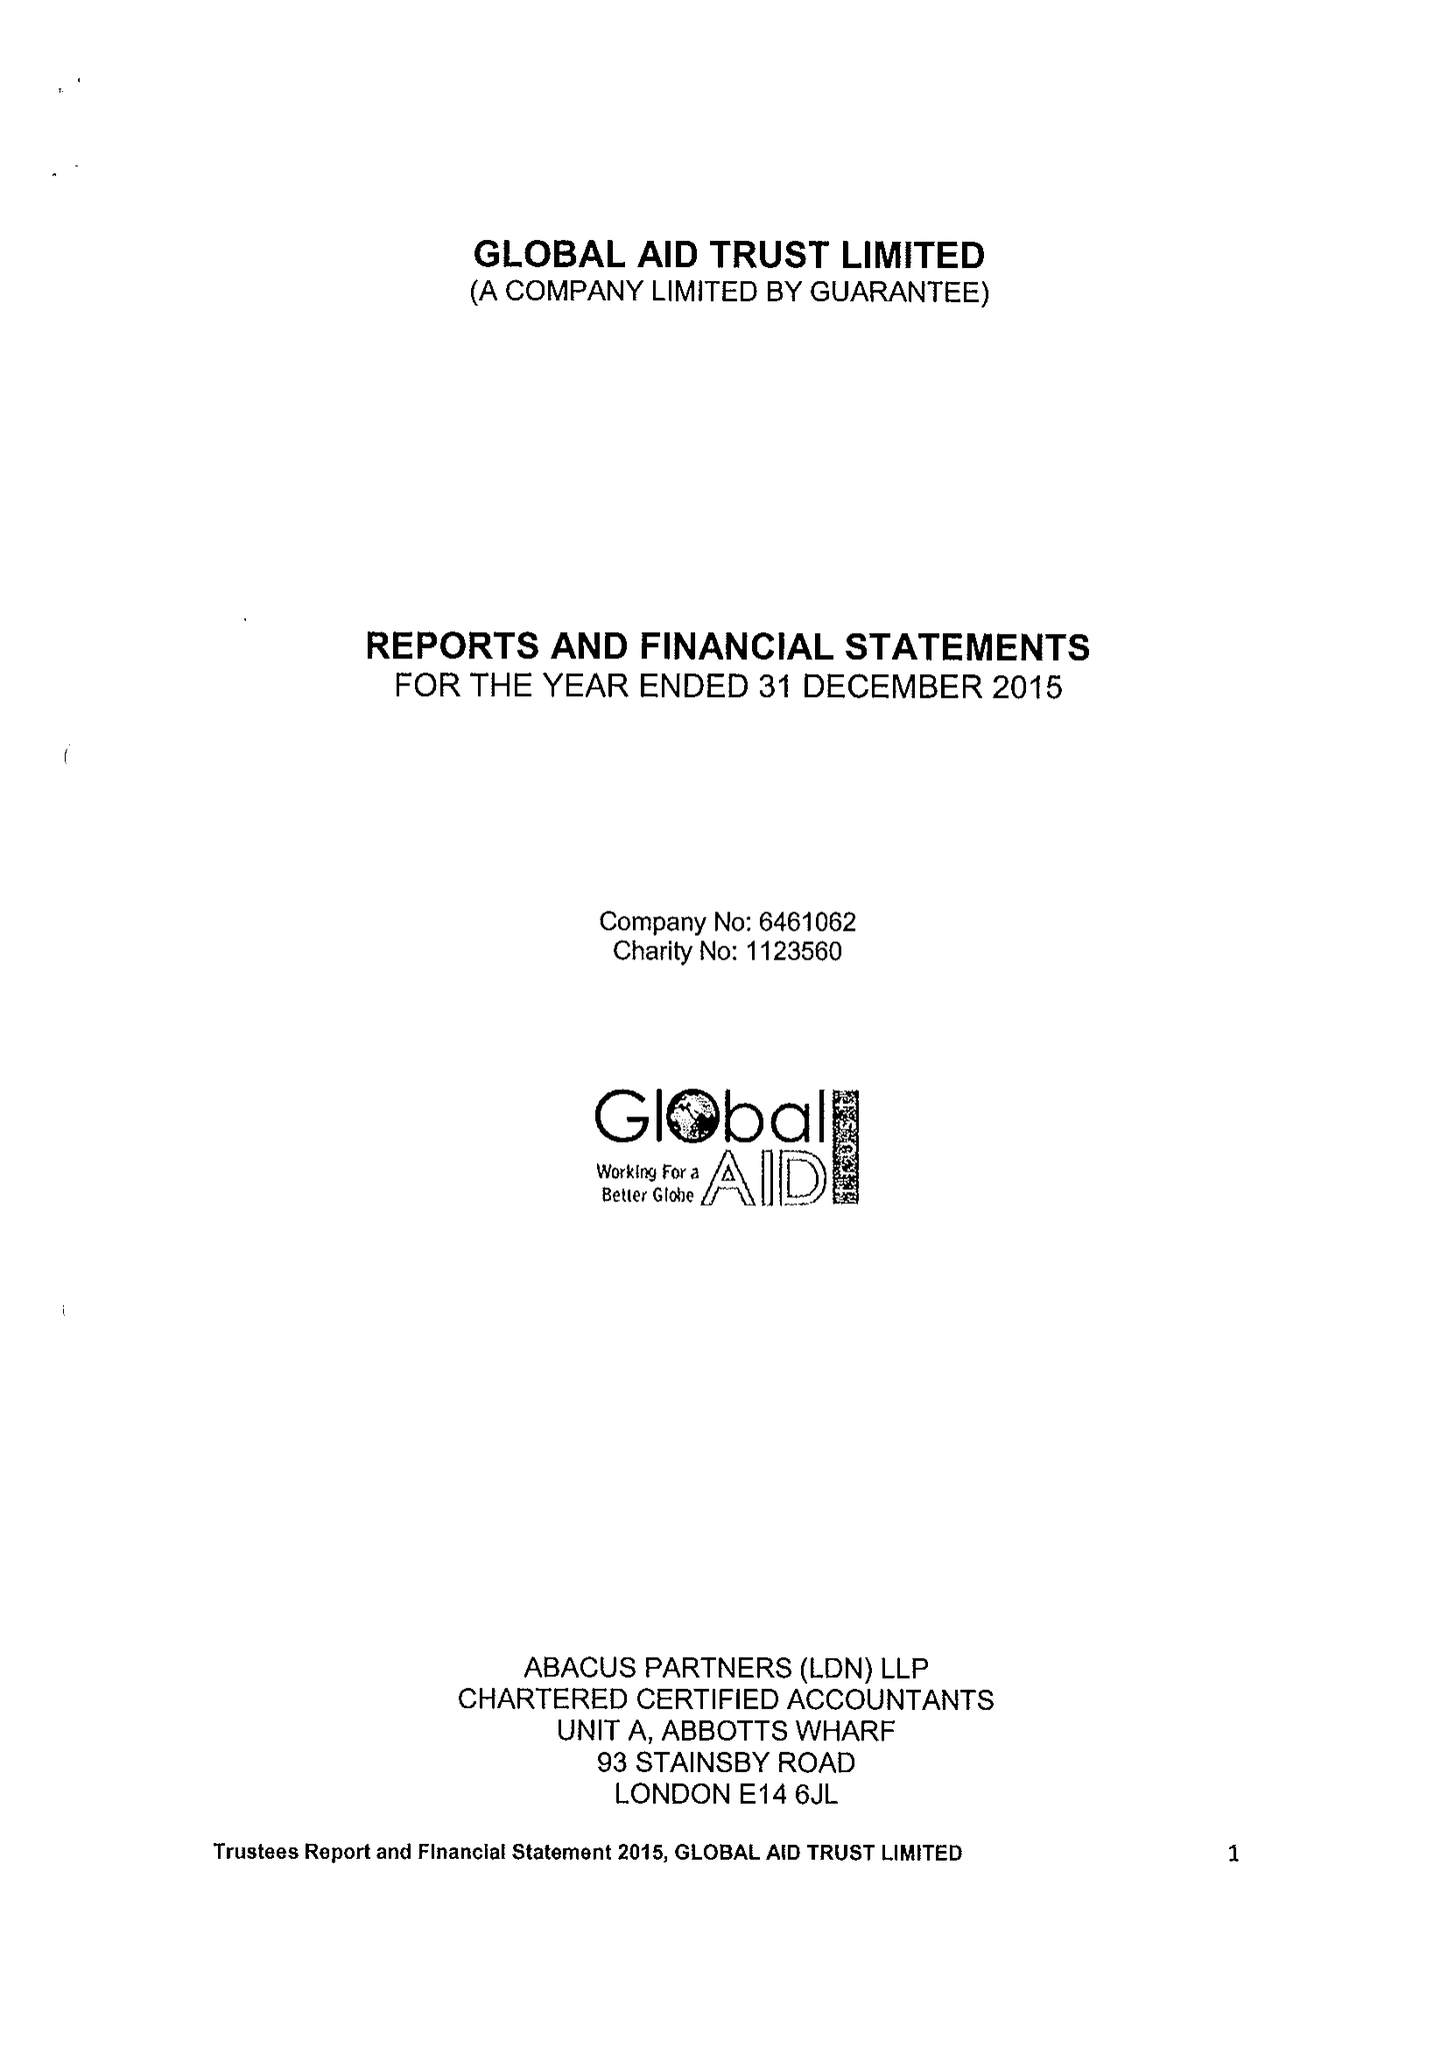What is the value for the address__street_line?
Answer the question using a single word or phrase. 80A ASHFIELD STREET 